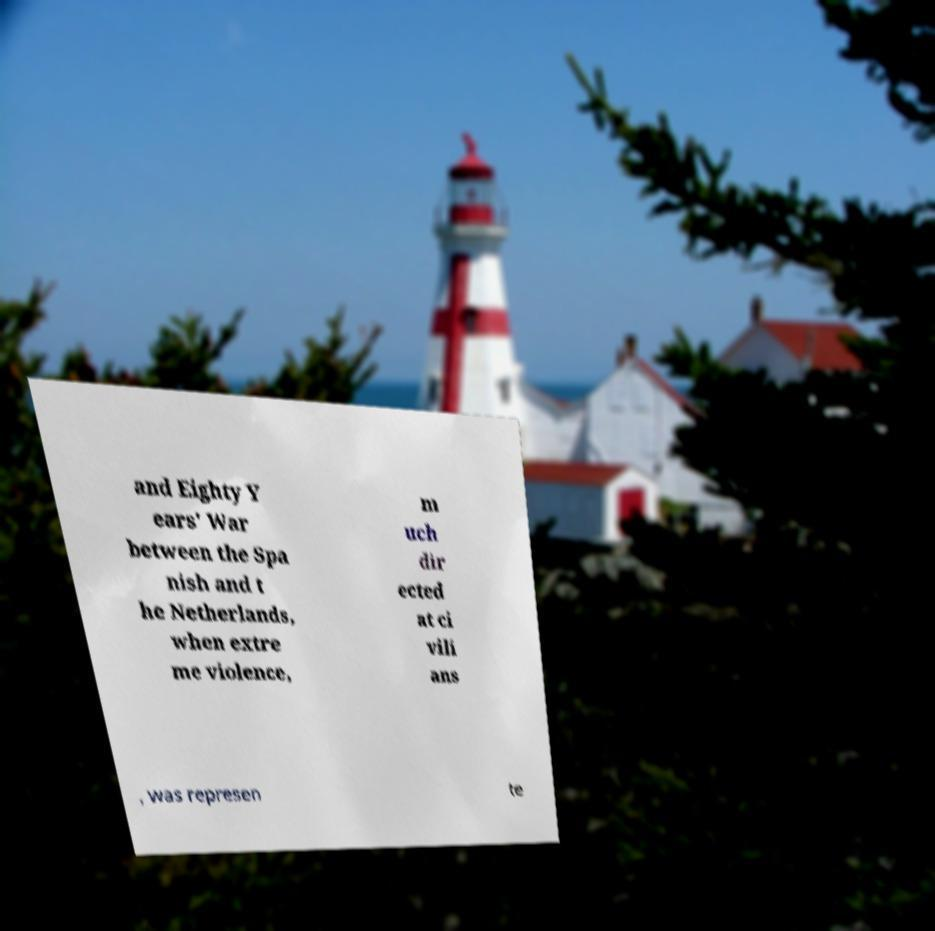I need the written content from this picture converted into text. Can you do that? and Eighty Y ears' War between the Spa nish and t he Netherlands, when extre me violence, m uch dir ected at ci vili ans , was represen te 